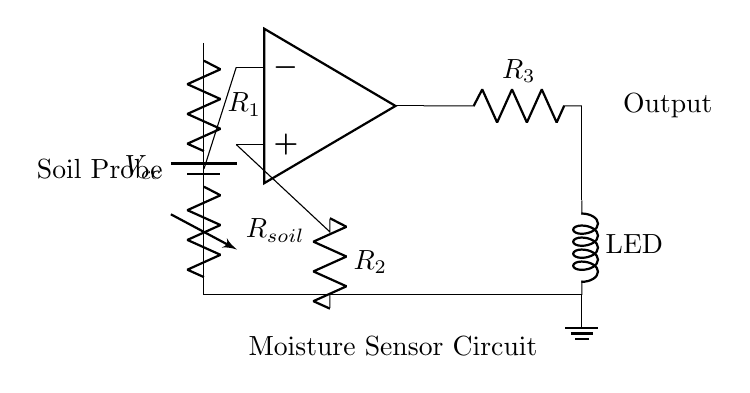What is the type of component represented by the symbol at the center? The central symbol is an operational amplifier, commonly denoted as op-amp, which is used for signal amplification in the circuit.
Answer: operational amplifier What does the resistor labeled R1 represent? R1 is a fixed resistor in this circuit that is part of a voltage divider, contributing to the measurement of moisture by interacting with the variable resistance of the soil probe.
Answer: fixed resistor Which component indicates the output of the circuit? The output of the circuit is indicated by the LED, which lights up based on the moisture content sensed by the soil probe, showing the circuit's functionality.
Answer: LED What does the variable resistor labeled Rsoil signify? Rsoil represents the variable resistance of the soil moisture sensor, which changes according to the moisture level in the soil, affecting the overall circuit behavior.
Answer: variable resistor How many resistors are there in the circuit? There are three resistors in the circuit: R1, R2, and R3, which perform different roles in the voltage measurement and signal processing.
Answer: three What is the role of the voltage divider in this circuit? The voltage divider formed by R1 and Rsoil is designed to create a specific voltage level that the op-amp will use for comparison, essential for moisture detection.
Answer: create reference voltage What might happen if Rsoil has a very high resistance? If Rsoil has high resistance, it would indicate low moisture content in the soil, leading to a lower output voltage from the op-amp, resulting in a dim or off LED state.
Answer: LED dim/off 